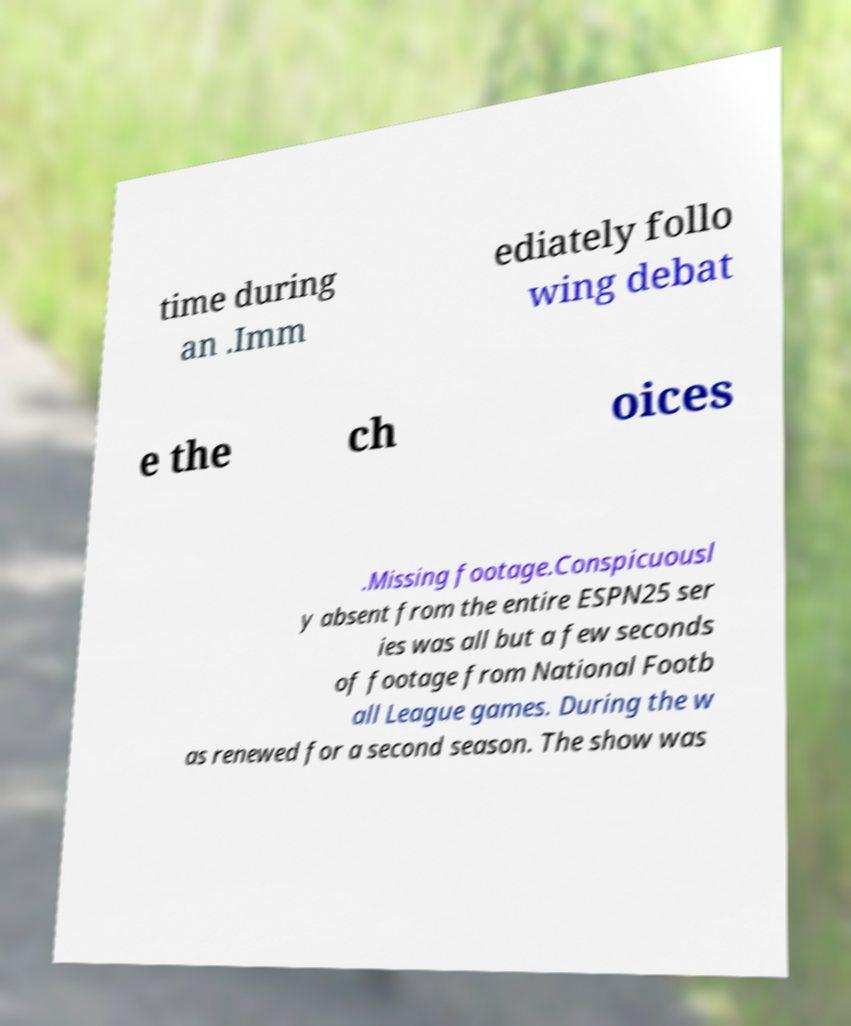There's text embedded in this image that I need extracted. Can you transcribe it verbatim? time during an .Imm ediately follo wing debat e the ch oices .Missing footage.Conspicuousl y absent from the entire ESPN25 ser ies was all but a few seconds of footage from National Footb all League games. During the w as renewed for a second season. The show was 